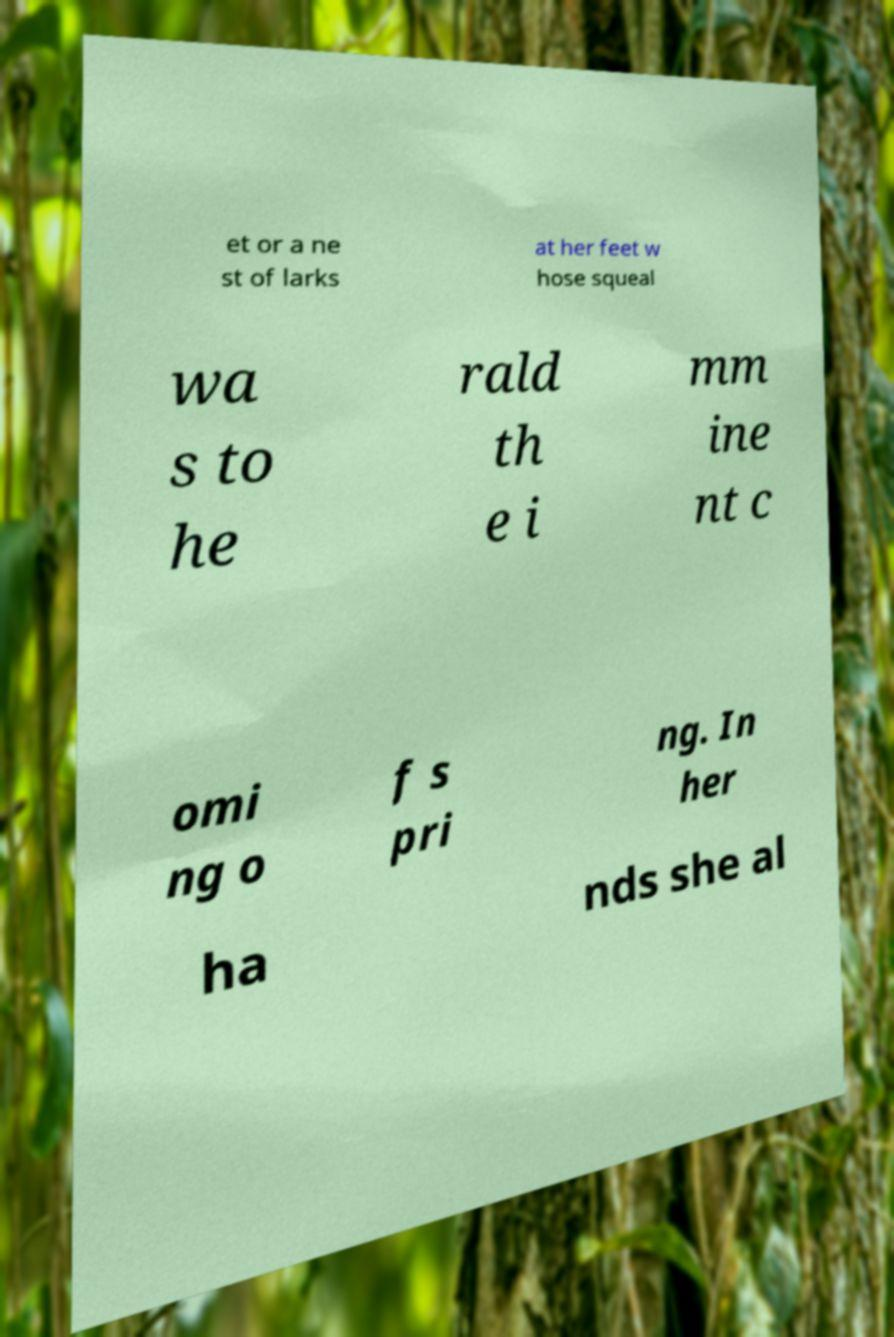Can you accurately transcribe the text from the provided image for me? et or a ne st of larks at her feet w hose squeal wa s to he rald th e i mm ine nt c omi ng o f s pri ng. In her ha nds she al 